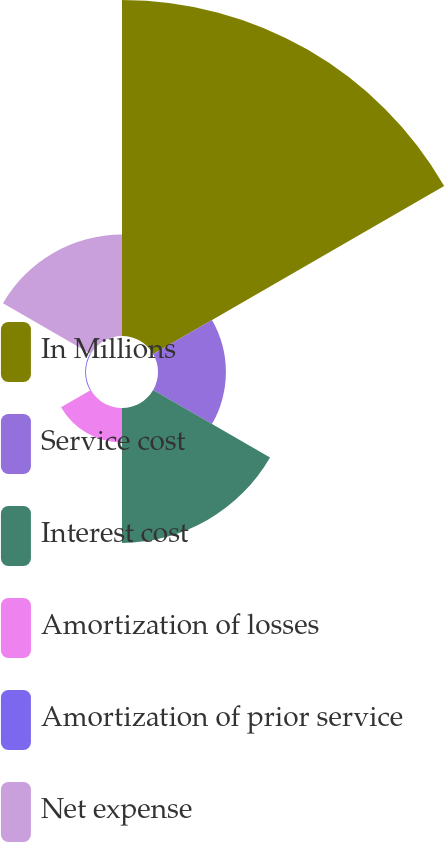Convert chart to OTSL. <chart><loc_0><loc_0><loc_500><loc_500><pie_chart><fcel>In Millions<fcel>Service cost<fcel>Interest cost<fcel>Amortization of losses<fcel>Amortization of prior service<fcel>Net expense<nl><fcel>49.73%<fcel>10.05%<fcel>19.97%<fcel>5.09%<fcel>0.13%<fcel>15.01%<nl></chart> 